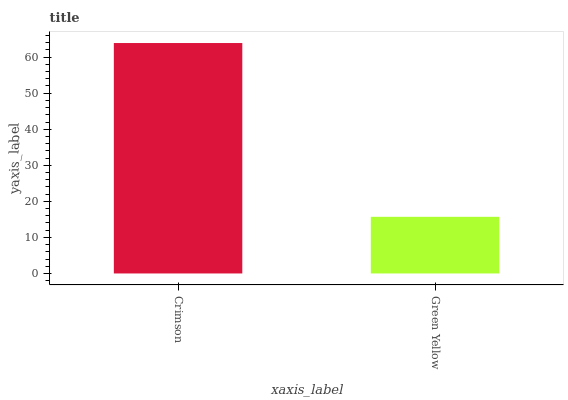Is Green Yellow the minimum?
Answer yes or no. Yes. Is Crimson the maximum?
Answer yes or no. Yes. Is Green Yellow the maximum?
Answer yes or no. No. Is Crimson greater than Green Yellow?
Answer yes or no. Yes. Is Green Yellow less than Crimson?
Answer yes or no. Yes. Is Green Yellow greater than Crimson?
Answer yes or no. No. Is Crimson less than Green Yellow?
Answer yes or no. No. Is Crimson the high median?
Answer yes or no. Yes. Is Green Yellow the low median?
Answer yes or no. Yes. Is Green Yellow the high median?
Answer yes or no. No. Is Crimson the low median?
Answer yes or no. No. 